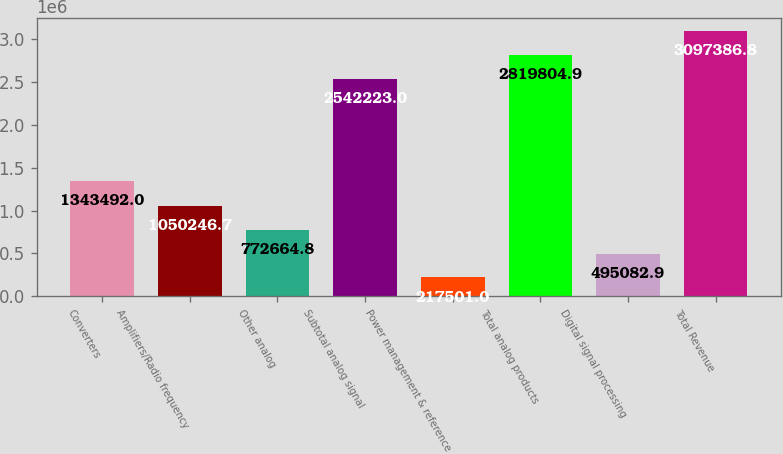Convert chart to OTSL. <chart><loc_0><loc_0><loc_500><loc_500><bar_chart><fcel>Converters<fcel>Amplifiers/Radio frequency<fcel>Other analog<fcel>Subtotal analog signal<fcel>Power management & reference<fcel>Total analog products<fcel>Digital signal processing<fcel>Total Revenue<nl><fcel>1.34349e+06<fcel>1.05025e+06<fcel>772665<fcel>2.54222e+06<fcel>217501<fcel>2.8198e+06<fcel>495083<fcel>3.09739e+06<nl></chart> 